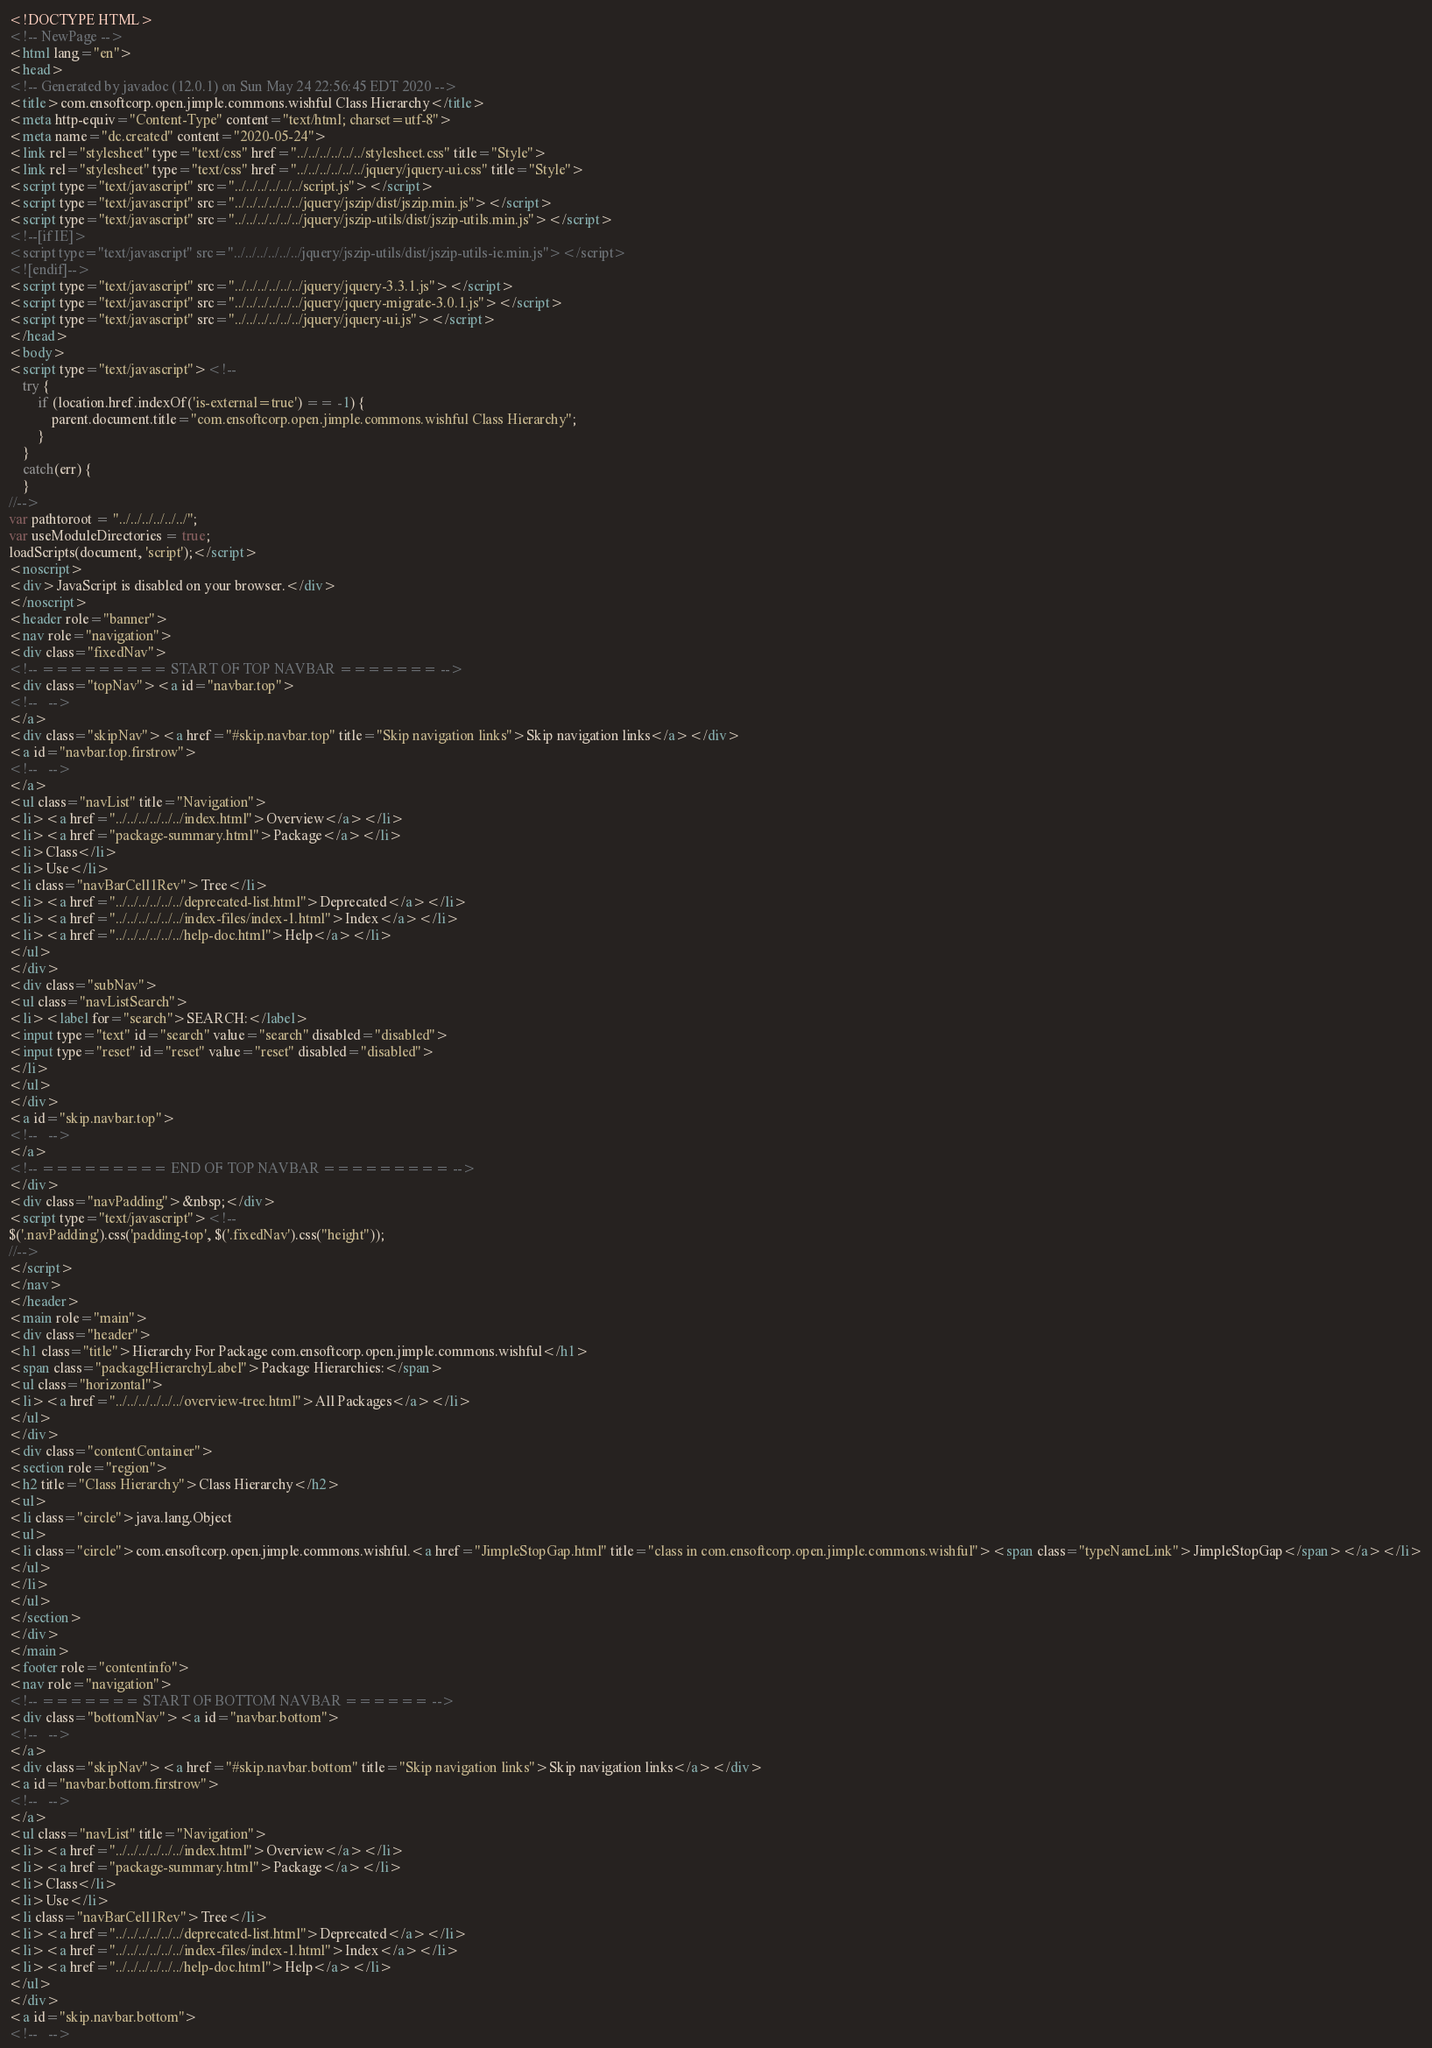Convert code to text. <code><loc_0><loc_0><loc_500><loc_500><_HTML_><!DOCTYPE HTML>
<!-- NewPage -->
<html lang="en">
<head>
<!-- Generated by javadoc (12.0.1) on Sun May 24 22:56:45 EDT 2020 -->
<title>com.ensoftcorp.open.jimple.commons.wishful Class Hierarchy</title>
<meta http-equiv="Content-Type" content="text/html; charset=utf-8">
<meta name="dc.created" content="2020-05-24">
<link rel="stylesheet" type="text/css" href="../../../../../../stylesheet.css" title="Style">
<link rel="stylesheet" type="text/css" href="../../../../../../jquery/jquery-ui.css" title="Style">
<script type="text/javascript" src="../../../../../../script.js"></script>
<script type="text/javascript" src="../../../../../../jquery/jszip/dist/jszip.min.js"></script>
<script type="text/javascript" src="../../../../../../jquery/jszip-utils/dist/jszip-utils.min.js"></script>
<!--[if IE]>
<script type="text/javascript" src="../../../../../../jquery/jszip-utils/dist/jszip-utils-ie.min.js"></script>
<![endif]-->
<script type="text/javascript" src="../../../../../../jquery/jquery-3.3.1.js"></script>
<script type="text/javascript" src="../../../../../../jquery/jquery-migrate-3.0.1.js"></script>
<script type="text/javascript" src="../../../../../../jquery/jquery-ui.js"></script>
</head>
<body>
<script type="text/javascript"><!--
    try {
        if (location.href.indexOf('is-external=true') == -1) {
            parent.document.title="com.ensoftcorp.open.jimple.commons.wishful Class Hierarchy";
        }
    }
    catch(err) {
    }
//-->
var pathtoroot = "../../../../../../";
var useModuleDirectories = true;
loadScripts(document, 'script');</script>
<noscript>
<div>JavaScript is disabled on your browser.</div>
</noscript>
<header role="banner">
<nav role="navigation">
<div class="fixedNav">
<!-- ========= START OF TOP NAVBAR ======= -->
<div class="topNav"><a id="navbar.top">
<!--   -->
</a>
<div class="skipNav"><a href="#skip.navbar.top" title="Skip navigation links">Skip navigation links</a></div>
<a id="navbar.top.firstrow">
<!--   -->
</a>
<ul class="navList" title="Navigation">
<li><a href="../../../../../../index.html">Overview</a></li>
<li><a href="package-summary.html">Package</a></li>
<li>Class</li>
<li>Use</li>
<li class="navBarCell1Rev">Tree</li>
<li><a href="../../../../../../deprecated-list.html">Deprecated</a></li>
<li><a href="../../../../../../index-files/index-1.html">Index</a></li>
<li><a href="../../../../../../help-doc.html">Help</a></li>
</ul>
</div>
<div class="subNav">
<ul class="navListSearch">
<li><label for="search">SEARCH:</label>
<input type="text" id="search" value="search" disabled="disabled">
<input type="reset" id="reset" value="reset" disabled="disabled">
</li>
</ul>
</div>
<a id="skip.navbar.top">
<!--   -->
</a>
<!-- ========= END OF TOP NAVBAR ========= -->
</div>
<div class="navPadding">&nbsp;</div>
<script type="text/javascript"><!--
$('.navPadding').css('padding-top', $('.fixedNav').css("height"));
//-->
</script>
</nav>
</header>
<main role="main">
<div class="header">
<h1 class="title">Hierarchy For Package com.ensoftcorp.open.jimple.commons.wishful</h1>
<span class="packageHierarchyLabel">Package Hierarchies:</span>
<ul class="horizontal">
<li><a href="../../../../../../overview-tree.html">All Packages</a></li>
</ul>
</div>
<div class="contentContainer">
<section role="region">
<h2 title="Class Hierarchy">Class Hierarchy</h2>
<ul>
<li class="circle">java.lang.Object
<ul>
<li class="circle">com.ensoftcorp.open.jimple.commons.wishful.<a href="JimpleStopGap.html" title="class in com.ensoftcorp.open.jimple.commons.wishful"><span class="typeNameLink">JimpleStopGap</span></a></li>
</ul>
</li>
</ul>
</section>
</div>
</main>
<footer role="contentinfo">
<nav role="navigation">
<!-- ======= START OF BOTTOM NAVBAR ====== -->
<div class="bottomNav"><a id="navbar.bottom">
<!--   -->
</a>
<div class="skipNav"><a href="#skip.navbar.bottom" title="Skip navigation links">Skip navigation links</a></div>
<a id="navbar.bottom.firstrow">
<!--   -->
</a>
<ul class="navList" title="Navigation">
<li><a href="../../../../../../index.html">Overview</a></li>
<li><a href="package-summary.html">Package</a></li>
<li>Class</li>
<li>Use</li>
<li class="navBarCell1Rev">Tree</li>
<li><a href="../../../../../../deprecated-list.html">Deprecated</a></li>
<li><a href="../../../../../../index-files/index-1.html">Index</a></li>
<li><a href="../../../../../../help-doc.html">Help</a></li>
</ul>
</div>
<a id="skip.navbar.bottom">
<!--   --></code> 